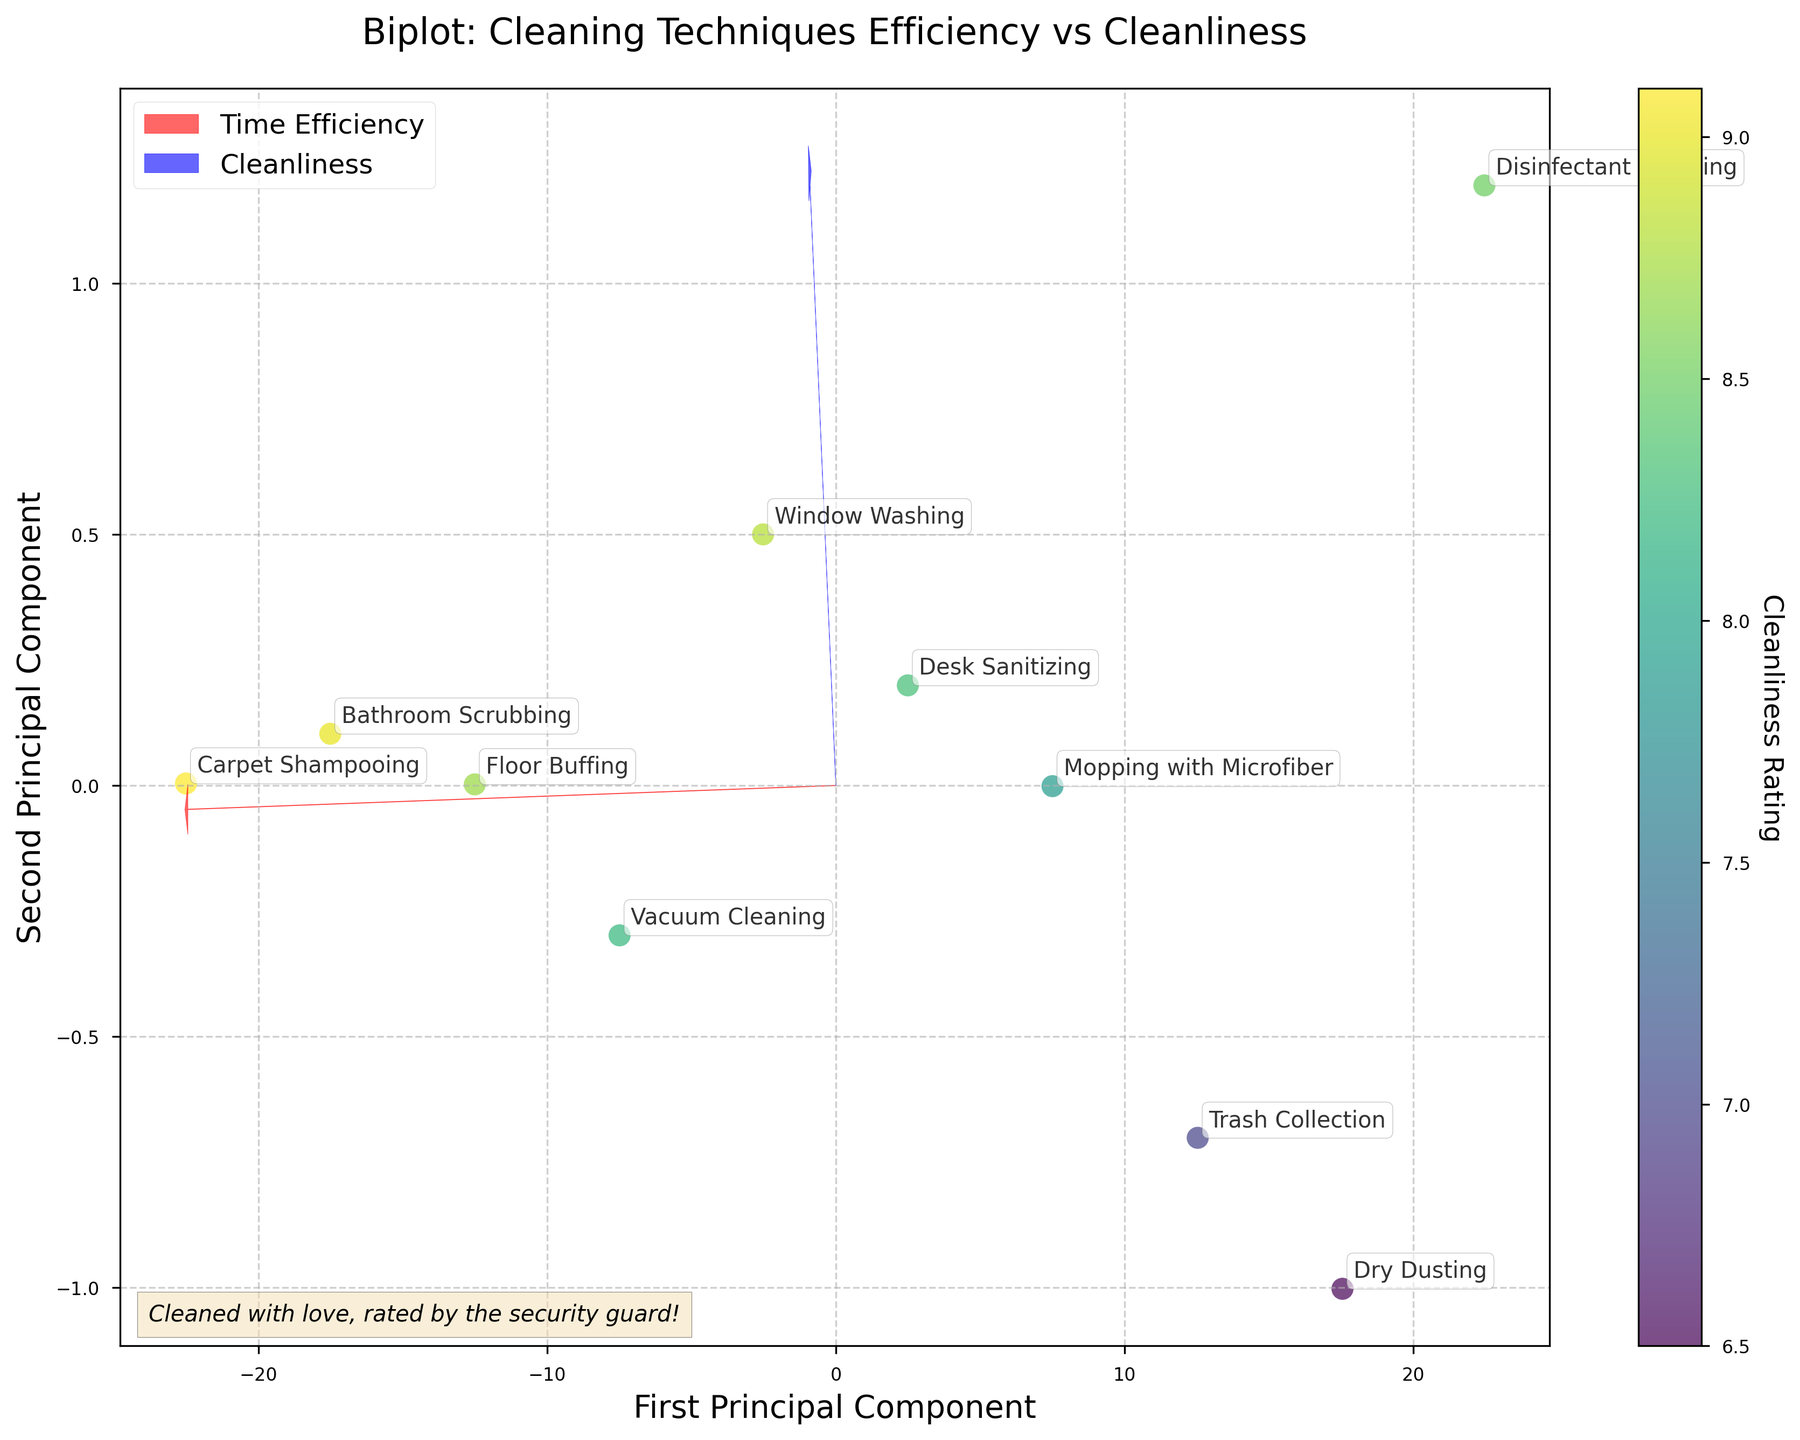What's the title of the plot? The title can be found at the top of the figure, which should summarize the main topic of the chart.
Answer: Biplot: Cleaning Techniques Efficiency vs Cleanliness How many cleaning techniques are shown in the plot? You can count the number of different labeled points in the plot.
Answer: 10 Which cleaning technique has the highest cleanliness rating? Look at the color intensity on the colorbar and identify the point with the highest cleanliness rating.
Answer: Carpet Shampooing Which feature vector indicates time efficiency? The label and direction of the feature vector can be used to identify which one corresponds to time efficiency.
Answer: The red arrow How does Mopping with Microfiber compare to Trash Collection in terms of time efficiency and cleanliness? Check the positions of the points labeled 'Mopping with Microfiber' and 'Trash Collection' on the plot. Note their coordinates relative to both principal components to compare them.
Answer: Mopping is more time-efficient but rated slightly lower in cleanliness Which data point is closest to the origin in the principal component space? Identify which labeled point is nearest to the (0,0) location in the PC space, where principal components originate.
Answer: Desk Sanitizing If we want the highest cleanliness rating, should we focus on techniques with higher or lower time efficiency? Compare the cleanliness ratings of techniques with higher versus lower time efficiency and see which has a higher rating generally.
Answer: Higher cleanliness ratings are generally seen with higher time efficiency techniques Which cleaning technique offers a good balance of time efficiency and cleanliness? Look for a point that is relatively central, indicating a balance between both principal components, and check its time efficiency and cleanliness rating.
Answer: Desk Sanitizing What insight does the plot provide about the relationship between time efficiency and cleanliness? Summarize the general trend observed in the plot regarding the relationship between time efficiency and cleanliness.
Answer: Generally, higher time efficiency tends to correspond with higher cleanliness ratings 